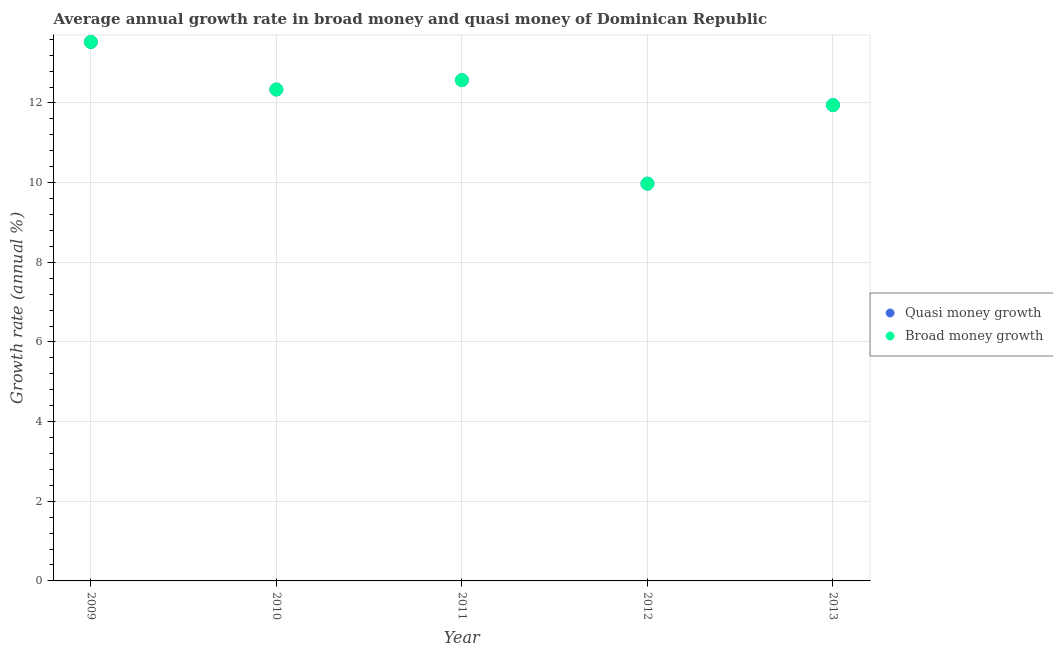What is the annual growth rate in quasi money in 2011?
Provide a short and direct response. 12.57. Across all years, what is the maximum annual growth rate in quasi money?
Keep it short and to the point. 13.53. Across all years, what is the minimum annual growth rate in quasi money?
Give a very brief answer. 9.97. What is the total annual growth rate in broad money in the graph?
Your answer should be compact. 60.36. What is the difference between the annual growth rate in quasi money in 2011 and that in 2013?
Ensure brevity in your answer.  0.63. What is the difference between the annual growth rate in quasi money in 2011 and the annual growth rate in broad money in 2012?
Provide a succinct answer. 2.6. What is the average annual growth rate in broad money per year?
Your response must be concise. 12.07. In the year 2012, what is the difference between the annual growth rate in broad money and annual growth rate in quasi money?
Your answer should be very brief. 0. What is the ratio of the annual growth rate in quasi money in 2010 to that in 2011?
Keep it short and to the point. 0.98. Is the difference between the annual growth rate in broad money in 2009 and 2013 greater than the difference between the annual growth rate in quasi money in 2009 and 2013?
Your answer should be compact. No. What is the difference between the highest and the second highest annual growth rate in quasi money?
Your answer should be compact. 0.96. What is the difference between the highest and the lowest annual growth rate in quasi money?
Offer a terse response. 3.56. In how many years, is the annual growth rate in broad money greater than the average annual growth rate in broad money taken over all years?
Make the answer very short. 3. Does the annual growth rate in broad money monotonically increase over the years?
Offer a very short reply. No. Is the annual growth rate in broad money strictly less than the annual growth rate in quasi money over the years?
Offer a terse response. No. How many dotlines are there?
Offer a very short reply. 2. What is the difference between two consecutive major ticks on the Y-axis?
Provide a succinct answer. 2. Are the values on the major ticks of Y-axis written in scientific E-notation?
Your answer should be very brief. No. Does the graph contain any zero values?
Make the answer very short. No. What is the title of the graph?
Ensure brevity in your answer.  Average annual growth rate in broad money and quasi money of Dominican Republic. Does "Non-residents" appear as one of the legend labels in the graph?
Offer a very short reply. No. What is the label or title of the Y-axis?
Your answer should be very brief. Growth rate (annual %). What is the Growth rate (annual %) of Quasi money growth in 2009?
Your answer should be very brief. 13.53. What is the Growth rate (annual %) in Broad money growth in 2009?
Ensure brevity in your answer.  13.53. What is the Growth rate (annual %) of Quasi money growth in 2010?
Provide a succinct answer. 12.34. What is the Growth rate (annual %) in Broad money growth in 2010?
Offer a very short reply. 12.34. What is the Growth rate (annual %) of Quasi money growth in 2011?
Offer a very short reply. 12.57. What is the Growth rate (annual %) of Broad money growth in 2011?
Keep it short and to the point. 12.57. What is the Growth rate (annual %) in Quasi money growth in 2012?
Provide a succinct answer. 9.97. What is the Growth rate (annual %) in Broad money growth in 2012?
Offer a terse response. 9.97. What is the Growth rate (annual %) of Quasi money growth in 2013?
Offer a very short reply. 11.95. What is the Growth rate (annual %) in Broad money growth in 2013?
Provide a succinct answer. 11.95. Across all years, what is the maximum Growth rate (annual %) in Quasi money growth?
Give a very brief answer. 13.53. Across all years, what is the maximum Growth rate (annual %) in Broad money growth?
Provide a succinct answer. 13.53. Across all years, what is the minimum Growth rate (annual %) of Quasi money growth?
Keep it short and to the point. 9.97. Across all years, what is the minimum Growth rate (annual %) in Broad money growth?
Provide a short and direct response. 9.97. What is the total Growth rate (annual %) of Quasi money growth in the graph?
Ensure brevity in your answer.  60.36. What is the total Growth rate (annual %) of Broad money growth in the graph?
Make the answer very short. 60.36. What is the difference between the Growth rate (annual %) of Quasi money growth in 2009 and that in 2010?
Offer a terse response. 1.19. What is the difference between the Growth rate (annual %) in Broad money growth in 2009 and that in 2010?
Your answer should be compact. 1.19. What is the difference between the Growth rate (annual %) of Quasi money growth in 2009 and that in 2011?
Your answer should be very brief. 0.96. What is the difference between the Growth rate (annual %) in Broad money growth in 2009 and that in 2011?
Ensure brevity in your answer.  0.96. What is the difference between the Growth rate (annual %) of Quasi money growth in 2009 and that in 2012?
Your answer should be compact. 3.56. What is the difference between the Growth rate (annual %) in Broad money growth in 2009 and that in 2012?
Keep it short and to the point. 3.56. What is the difference between the Growth rate (annual %) of Quasi money growth in 2009 and that in 2013?
Offer a terse response. 1.59. What is the difference between the Growth rate (annual %) in Broad money growth in 2009 and that in 2013?
Make the answer very short. 1.59. What is the difference between the Growth rate (annual %) of Quasi money growth in 2010 and that in 2011?
Offer a very short reply. -0.23. What is the difference between the Growth rate (annual %) of Broad money growth in 2010 and that in 2011?
Ensure brevity in your answer.  -0.23. What is the difference between the Growth rate (annual %) of Quasi money growth in 2010 and that in 2012?
Offer a terse response. 2.36. What is the difference between the Growth rate (annual %) in Broad money growth in 2010 and that in 2012?
Make the answer very short. 2.36. What is the difference between the Growth rate (annual %) of Quasi money growth in 2010 and that in 2013?
Keep it short and to the point. 0.39. What is the difference between the Growth rate (annual %) in Broad money growth in 2010 and that in 2013?
Offer a terse response. 0.39. What is the difference between the Growth rate (annual %) of Quasi money growth in 2011 and that in 2012?
Your answer should be very brief. 2.6. What is the difference between the Growth rate (annual %) of Broad money growth in 2011 and that in 2012?
Offer a very short reply. 2.6. What is the difference between the Growth rate (annual %) of Quasi money growth in 2011 and that in 2013?
Your answer should be compact. 0.63. What is the difference between the Growth rate (annual %) of Broad money growth in 2011 and that in 2013?
Offer a very short reply. 0.63. What is the difference between the Growth rate (annual %) of Quasi money growth in 2012 and that in 2013?
Make the answer very short. -1.97. What is the difference between the Growth rate (annual %) in Broad money growth in 2012 and that in 2013?
Your answer should be very brief. -1.97. What is the difference between the Growth rate (annual %) of Quasi money growth in 2009 and the Growth rate (annual %) of Broad money growth in 2010?
Offer a terse response. 1.19. What is the difference between the Growth rate (annual %) in Quasi money growth in 2009 and the Growth rate (annual %) in Broad money growth in 2011?
Offer a terse response. 0.96. What is the difference between the Growth rate (annual %) of Quasi money growth in 2009 and the Growth rate (annual %) of Broad money growth in 2012?
Offer a very short reply. 3.56. What is the difference between the Growth rate (annual %) of Quasi money growth in 2009 and the Growth rate (annual %) of Broad money growth in 2013?
Give a very brief answer. 1.59. What is the difference between the Growth rate (annual %) of Quasi money growth in 2010 and the Growth rate (annual %) of Broad money growth in 2011?
Offer a terse response. -0.23. What is the difference between the Growth rate (annual %) of Quasi money growth in 2010 and the Growth rate (annual %) of Broad money growth in 2012?
Provide a short and direct response. 2.36. What is the difference between the Growth rate (annual %) in Quasi money growth in 2010 and the Growth rate (annual %) in Broad money growth in 2013?
Give a very brief answer. 0.39. What is the difference between the Growth rate (annual %) in Quasi money growth in 2011 and the Growth rate (annual %) in Broad money growth in 2012?
Your answer should be very brief. 2.6. What is the difference between the Growth rate (annual %) of Quasi money growth in 2011 and the Growth rate (annual %) of Broad money growth in 2013?
Your answer should be compact. 0.63. What is the difference between the Growth rate (annual %) of Quasi money growth in 2012 and the Growth rate (annual %) of Broad money growth in 2013?
Your answer should be very brief. -1.97. What is the average Growth rate (annual %) of Quasi money growth per year?
Ensure brevity in your answer.  12.07. What is the average Growth rate (annual %) of Broad money growth per year?
Ensure brevity in your answer.  12.07. In the year 2009, what is the difference between the Growth rate (annual %) of Quasi money growth and Growth rate (annual %) of Broad money growth?
Your answer should be compact. 0. In the year 2011, what is the difference between the Growth rate (annual %) of Quasi money growth and Growth rate (annual %) of Broad money growth?
Your response must be concise. 0. In the year 2012, what is the difference between the Growth rate (annual %) in Quasi money growth and Growth rate (annual %) in Broad money growth?
Keep it short and to the point. 0. What is the ratio of the Growth rate (annual %) in Quasi money growth in 2009 to that in 2010?
Your answer should be very brief. 1.1. What is the ratio of the Growth rate (annual %) of Broad money growth in 2009 to that in 2010?
Ensure brevity in your answer.  1.1. What is the ratio of the Growth rate (annual %) in Quasi money growth in 2009 to that in 2011?
Ensure brevity in your answer.  1.08. What is the ratio of the Growth rate (annual %) of Broad money growth in 2009 to that in 2011?
Give a very brief answer. 1.08. What is the ratio of the Growth rate (annual %) of Quasi money growth in 2009 to that in 2012?
Give a very brief answer. 1.36. What is the ratio of the Growth rate (annual %) in Broad money growth in 2009 to that in 2012?
Provide a short and direct response. 1.36. What is the ratio of the Growth rate (annual %) of Quasi money growth in 2009 to that in 2013?
Your answer should be compact. 1.13. What is the ratio of the Growth rate (annual %) in Broad money growth in 2009 to that in 2013?
Make the answer very short. 1.13. What is the ratio of the Growth rate (annual %) of Quasi money growth in 2010 to that in 2011?
Ensure brevity in your answer.  0.98. What is the ratio of the Growth rate (annual %) in Broad money growth in 2010 to that in 2011?
Offer a terse response. 0.98. What is the ratio of the Growth rate (annual %) of Quasi money growth in 2010 to that in 2012?
Make the answer very short. 1.24. What is the ratio of the Growth rate (annual %) of Broad money growth in 2010 to that in 2012?
Give a very brief answer. 1.24. What is the ratio of the Growth rate (annual %) of Quasi money growth in 2010 to that in 2013?
Offer a very short reply. 1.03. What is the ratio of the Growth rate (annual %) of Broad money growth in 2010 to that in 2013?
Ensure brevity in your answer.  1.03. What is the ratio of the Growth rate (annual %) in Quasi money growth in 2011 to that in 2012?
Ensure brevity in your answer.  1.26. What is the ratio of the Growth rate (annual %) in Broad money growth in 2011 to that in 2012?
Keep it short and to the point. 1.26. What is the ratio of the Growth rate (annual %) of Quasi money growth in 2011 to that in 2013?
Ensure brevity in your answer.  1.05. What is the ratio of the Growth rate (annual %) in Broad money growth in 2011 to that in 2013?
Provide a short and direct response. 1.05. What is the ratio of the Growth rate (annual %) of Quasi money growth in 2012 to that in 2013?
Your answer should be compact. 0.83. What is the ratio of the Growth rate (annual %) of Broad money growth in 2012 to that in 2013?
Keep it short and to the point. 0.83. What is the difference between the highest and the second highest Growth rate (annual %) of Quasi money growth?
Offer a terse response. 0.96. What is the difference between the highest and the second highest Growth rate (annual %) in Broad money growth?
Ensure brevity in your answer.  0.96. What is the difference between the highest and the lowest Growth rate (annual %) in Quasi money growth?
Your answer should be very brief. 3.56. What is the difference between the highest and the lowest Growth rate (annual %) in Broad money growth?
Offer a terse response. 3.56. 